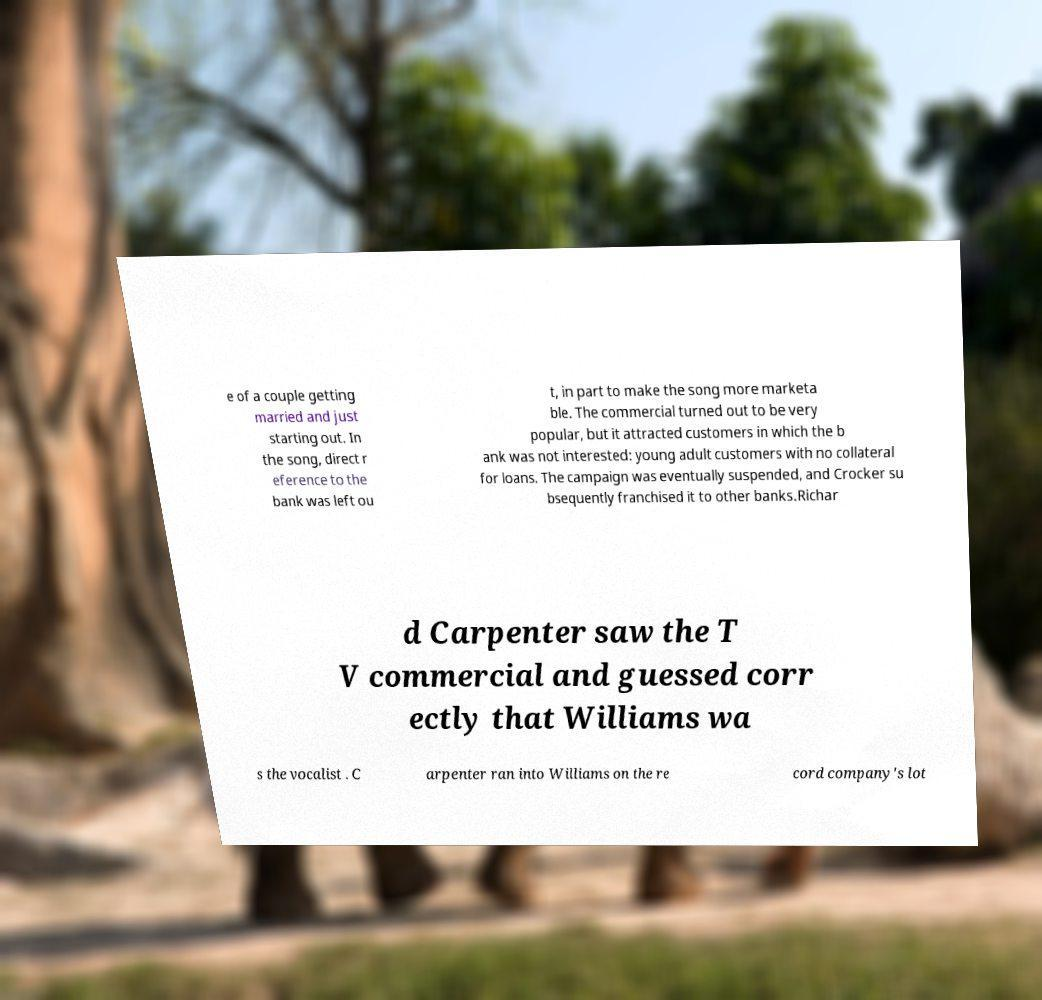Could you extract and type out the text from this image? e of a couple getting married and just starting out. In the song, direct r eference to the bank was left ou t, in part to make the song more marketa ble. The commercial turned out to be very popular, but it attracted customers in which the b ank was not interested: young adult customers with no collateral for loans. The campaign was eventually suspended, and Crocker su bsequently franchised it to other banks.Richar d Carpenter saw the T V commercial and guessed corr ectly that Williams wa s the vocalist . C arpenter ran into Williams on the re cord company's lot 